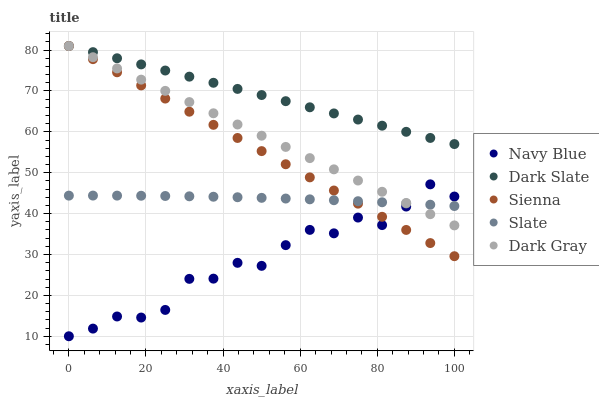Does Navy Blue have the minimum area under the curve?
Answer yes or no. Yes. Does Dark Slate have the maximum area under the curve?
Answer yes or no. Yes. Does Slate have the minimum area under the curve?
Answer yes or no. No. Does Slate have the maximum area under the curve?
Answer yes or no. No. Is Sienna the smoothest?
Answer yes or no. Yes. Is Navy Blue the roughest?
Answer yes or no. Yes. Is Slate the smoothest?
Answer yes or no. No. Is Slate the roughest?
Answer yes or no. No. Does Navy Blue have the lowest value?
Answer yes or no. Yes. Does Slate have the lowest value?
Answer yes or no. No. Does Dark Slate have the highest value?
Answer yes or no. Yes. Does Navy Blue have the highest value?
Answer yes or no. No. Is Navy Blue less than Dark Slate?
Answer yes or no. Yes. Is Dark Slate greater than Navy Blue?
Answer yes or no. Yes. Does Dark Gray intersect Slate?
Answer yes or no. Yes. Is Dark Gray less than Slate?
Answer yes or no. No. Is Dark Gray greater than Slate?
Answer yes or no. No. Does Navy Blue intersect Dark Slate?
Answer yes or no. No. 